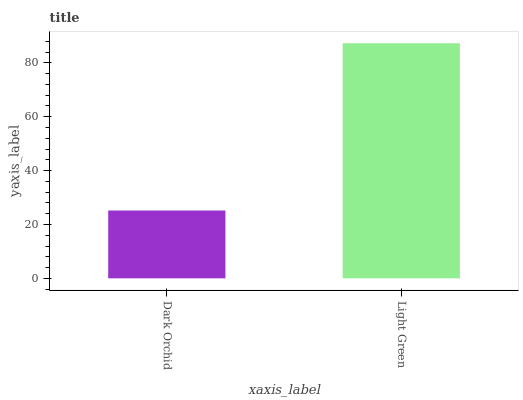Is Dark Orchid the minimum?
Answer yes or no. Yes. Is Light Green the maximum?
Answer yes or no. Yes. Is Light Green the minimum?
Answer yes or no. No. Is Light Green greater than Dark Orchid?
Answer yes or no. Yes. Is Dark Orchid less than Light Green?
Answer yes or no. Yes. Is Dark Orchid greater than Light Green?
Answer yes or no. No. Is Light Green less than Dark Orchid?
Answer yes or no. No. Is Light Green the high median?
Answer yes or no. Yes. Is Dark Orchid the low median?
Answer yes or no. Yes. Is Dark Orchid the high median?
Answer yes or no. No. Is Light Green the low median?
Answer yes or no. No. 